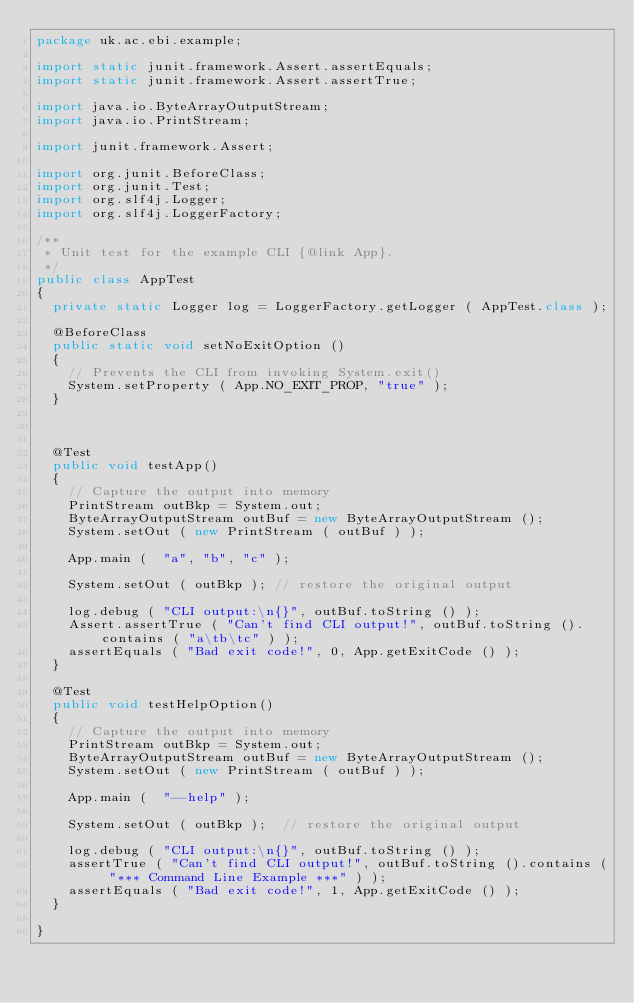<code> <loc_0><loc_0><loc_500><loc_500><_Java_>package uk.ac.ebi.example;

import static junit.framework.Assert.assertEquals;
import static junit.framework.Assert.assertTrue;

import java.io.ByteArrayOutputStream;
import java.io.PrintStream;

import junit.framework.Assert;

import org.junit.BeforeClass;
import org.junit.Test;
import org.slf4j.Logger;
import org.slf4j.LoggerFactory;

/**
 * Unit test for the example CLI {@link App}.
 */
public class AppTest
{
	private static Logger log = LoggerFactory.getLogger ( AppTest.class );

	@BeforeClass
	public static void setNoExitOption ()
	{
		// Prevents the CLI from invoking System.exit()
		System.setProperty ( App.NO_EXIT_PROP, "true" );
	}
	
	
	
	@Test
	public void testApp()
	{
		// Capture the output into memory
		PrintStream outBkp = System.out;
		ByteArrayOutputStream outBuf = new ByteArrayOutputStream ();
		System.setOut ( new PrintStream ( outBuf ) );
		
		App.main (  "a", "b", "c" );

		System.setOut ( outBkp ); // restore the original output
		
		log.debug ( "CLI output:\n{}", outBuf.toString () );
		Assert.assertTrue ( "Can't find CLI output!", outBuf.toString ().contains ( "a\tb\tc" ) );
		assertEquals ( "Bad exit code!", 0, App.getExitCode () );
	}

	@Test
	public void testHelpOption()
	{
		// Capture the output into memory
		PrintStream outBkp = System.out;
		ByteArrayOutputStream outBuf = new ByteArrayOutputStream ();
		System.setOut ( new PrintStream ( outBuf ) );

		App.main (  "--help" );
		
		System.setOut ( outBkp );  // restore the original output

		log.debug ( "CLI output:\n{}", outBuf.toString () );
		assertTrue ( "Can't find CLI output!", outBuf.toString ().contains ( "*** Command Line Example ***" ) );
		assertEquals ( "Bad exit code!", 1, App.getExitCode () );
	}

}
</code> 